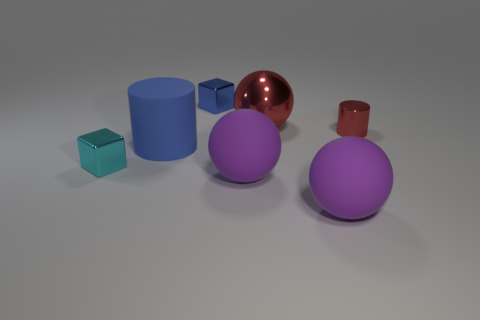How many purple spheres must be subtracted to get 1 purple spheres? 1 Subtract all gray cylinders. Subtract all green spheres. How many cylinders are left? 2 Add 2 big red objects. How many objects exist? 9 Subtract all cubes. How many objects are left? 5 Add 6 tiny shiny blocks. How many tiny shiny blocks are left? 8 Add 5 large blue rubber cylinders. How many large blue rubber cylinders exist? 6 Subtract 0 brown cubes. How many objects are left? 7 Subtract all big balls. Subtract all large rubber spheres. How many objects are left? 2 